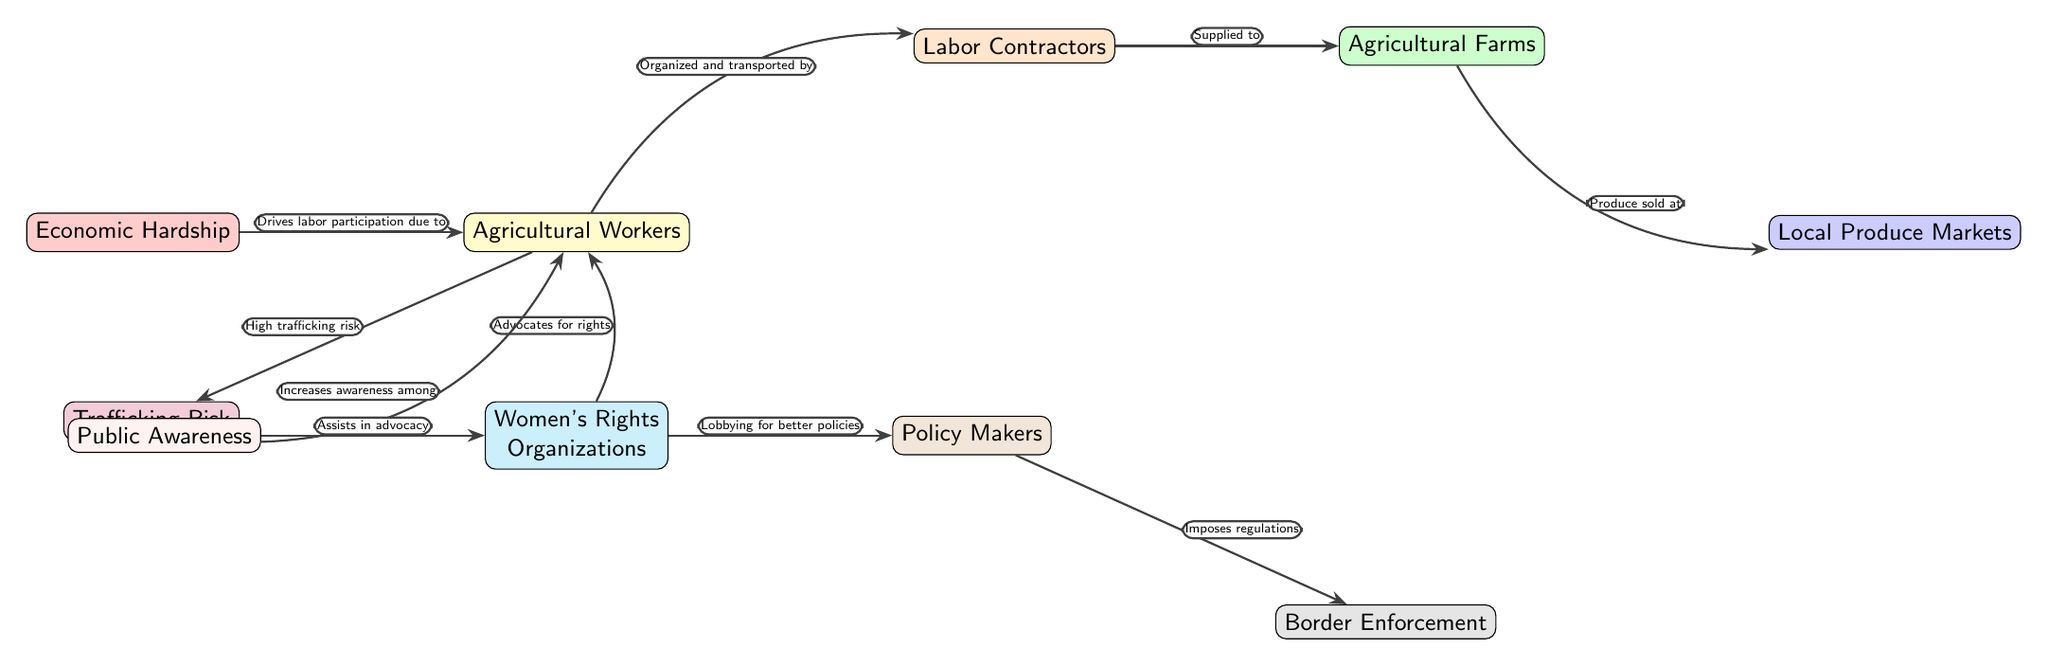What is the first node in the diagram? The first node in the diagram is "Agricultural Workers." This can be determined by looking at the diagram's layout, where this node is positioned at the topmost left side.
Answer: Agricultural Workers How many nodes are in the diagram? Counting all the distinct nodes, we find there are ten nodes. This includes all labeled elements in the diagram graphically represented.
Answer: 10 What drives labor participation according to the diagram? The diagram states that "Economic Hardship" drives labor participation due to its direct influence on "Agricultural Workers." This is indicated by the arrow connecting these two nodes.
Answer: Economic Hardship Who advocates for the rights of agricultural workers? The node specifically identified as advocating for the rights of agricultural workers is "Women's Rights Organizations." The diagram associates this node directly with "Agricultural Workers."
Answer: Women's Rights Organizations What is the relationship between agricultural workers and trafficking risk? The relationship indicated in the diagram is that there is a "High trafficking risk" associated with "Agricultural Workers." The arrow pointing from the workers to trafficking risk denotes this connection.
Answer: High trafficking risk Which node is responsible for imposing regulations? The node responsible for imposing regulations in the diagram is "Policy Makers." The arrow leading from "Policy Makers" connects it to "Border Enforcement," revealing its position in the regulatory process.
Answer: Policy Makers What does public awareness assist in? According to the diagram, "Public Awareness" assists in "Advocacy" for "Women's Rights Organizations." The corresponding arrows demonstrate this support relationship.
Answer: Advocacy In the diagram, how do "Labor Contractors" connect to "Agricultural Farms"? The connection is described with the label "Supplied to," indicating that "Labor Contractors" supply labor to "Agricultural Farms." This is shown by the arrow linking these two nodes.
Answer: Supplied to What role do "Women's Rights Organizations" play in relation to agricultural workers? "Women's Rights Organizations" advocate for the rights of "Agricultural Workers," as depicted by the arrow flowing from the organizations towards the workers, indicating proactive support.
Answer: Advocate for rights 